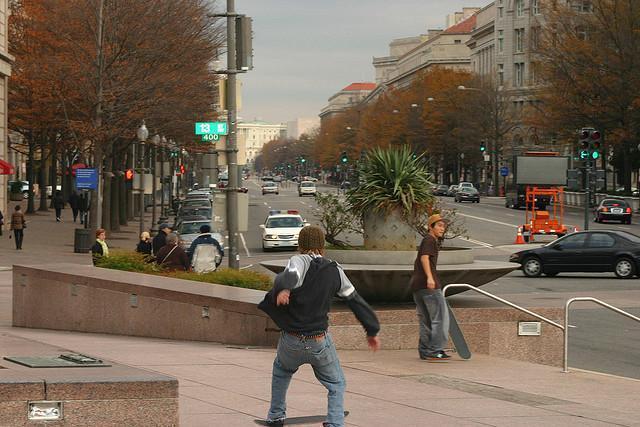Why plants are planted on roadside?
Select the correct answer and articulate reasoning with the following format: 'Answer: answer
Rationale: rationale.'
Options: Decorative purpose, wind breaks, climatic excesses, crop prevention. Answer: wind breaks.
Rationale: Plants make the area look nicer. 